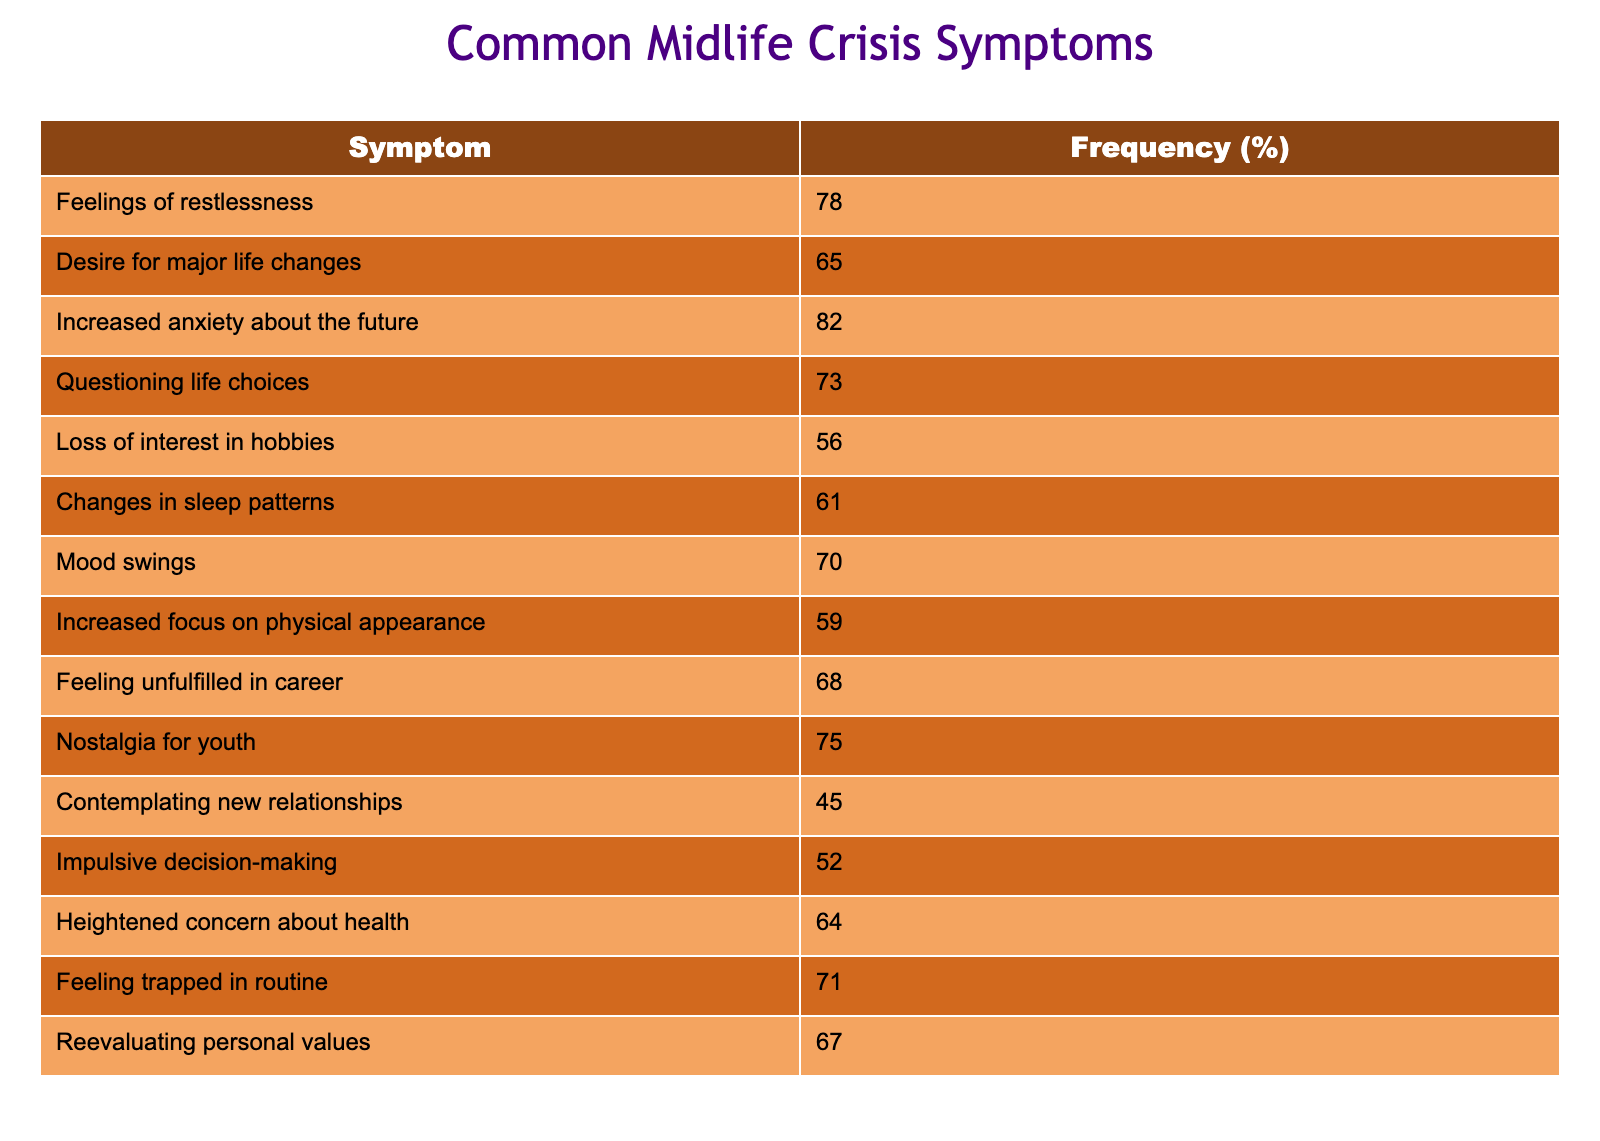What symptom has the highest frequency? By reviewing the frequency column of the table, the symptom "Increased anxiety about the future" has a frequency of 82%, which is higher than all other symptoms listed.
Answer: Increased anxiety about the future What is the frequency of "Loss of interest in hobbies"? The table shows that the "Loss of interest in hobbies" symptom has a frequency of 56%. This is directly read from the frequency column for that symptom.
Answer: 56% How many symptoms have a frequency of 70% or more? By examining the table, I count the symptoms with 70% or more frequency: "Feelings of restlessness" (78%), "Increased anxiety about the future" (82%), "Questioning life choices" (73%), "Mood swings" (70%), "Feeling trapped in routine" (71%), and "Nostalgia for youth" (75%). That makes a total of 6 symptoms.
Answer: 6 Is the frequency of "Contemplating new relationships" higher than "Changes in sleep patterns"? The frequency for "Contemplating new relationships" is 45%, while "Changes in sleep patterns" has a frequency of 61%. Since 45% is less than 61%, the statement is false.
Answer: No What is the average frequency of all the symptoms listed? To find the average, I first sum the frequencies: 78 + 65 + 82 + 73 + 56 + 61 + 70 + 59 + 68 + 75 + 45 + 52 + 64 + 71 + 67 = 1051. There are 15 symptoms, so the average frequency is 1051/15 = 70.07.
Answer: 70.07 